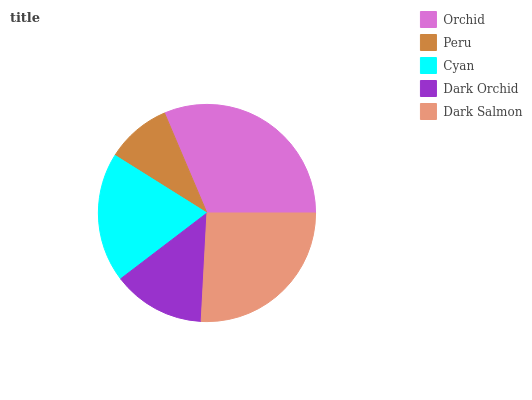Is Peru the minimum?
Answer yes or no. Yes. Is Orchid the maximum?
Answer yes or no. Yes. Is Cyan the minimum?
Answer yes or no. No. Is Cyan the maximum?
Answer yes or no. No. Is Cyan greater than Peru?
Answer yes or no. Yes. Is Peru less than Cyan?
Answer yes or no. Yes. Is Peru greater than Cyan?
Answer yes or no. No. Is Cyan less than Peru?
Answer yes or no. No. Is Cyan the high median?
Answer yes or no. Yes. Is Cyan the low median?
Answer yes or no. Yes. Is Peru the high median?
Answer yes or no. No. Is Dark Salmon the low median?
Answer yes or no. No. 